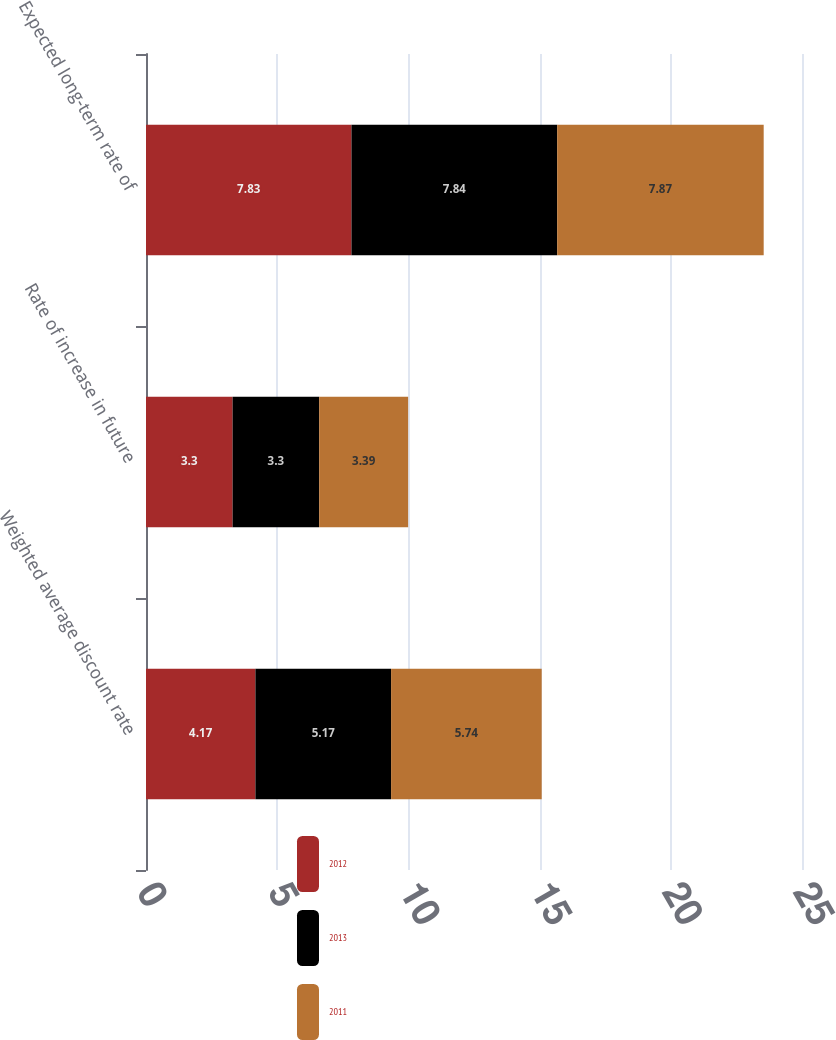<chart> <loc_0><loc_0><loc_500><loc_500><stacked_bar_chart><ecel><fcel>Weighted average discount rate<fcel>Rate of increase in future<fcel>Expected long-term rate of<nl><fcel>2012<fcel>4.17<fcel>3.3<fcel>7.83<nl><fcel>2013<fcel>5.17<fcel>3.3<fcel>7.84<nl><fcel>2011<fcel>5.74<fcel>3.39<fcel>7.87<nl></chart> 